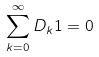<formula> <loc_0><loc_0><loc_500><loc_500>\sum _ { k = 0 } ^ { \infty } D _ { k } 1 = 0</formula> 